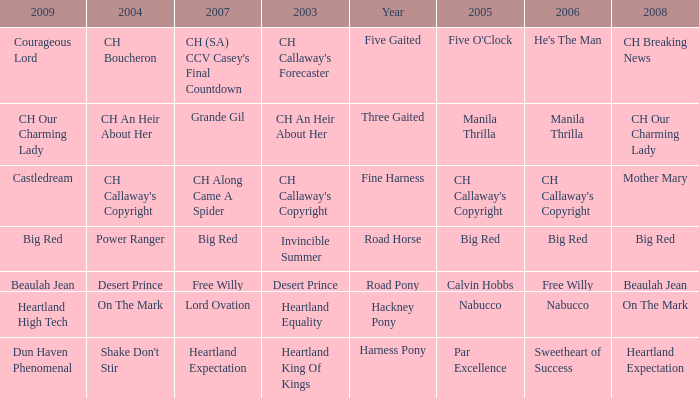What is the 2007 for the 2003 desert prince? Free Willy. 